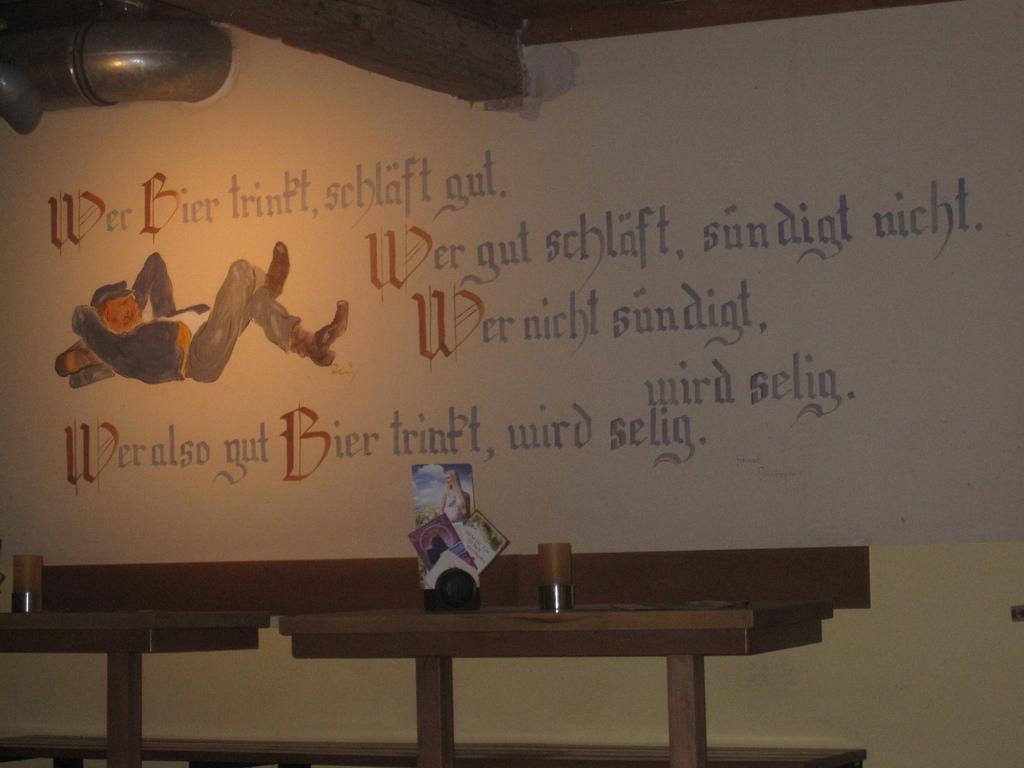Describe this image in one or two sentences. There are tables. On that there are some items. In the back there's a wall. On the wall something is written and there is a painting of a person lying. 